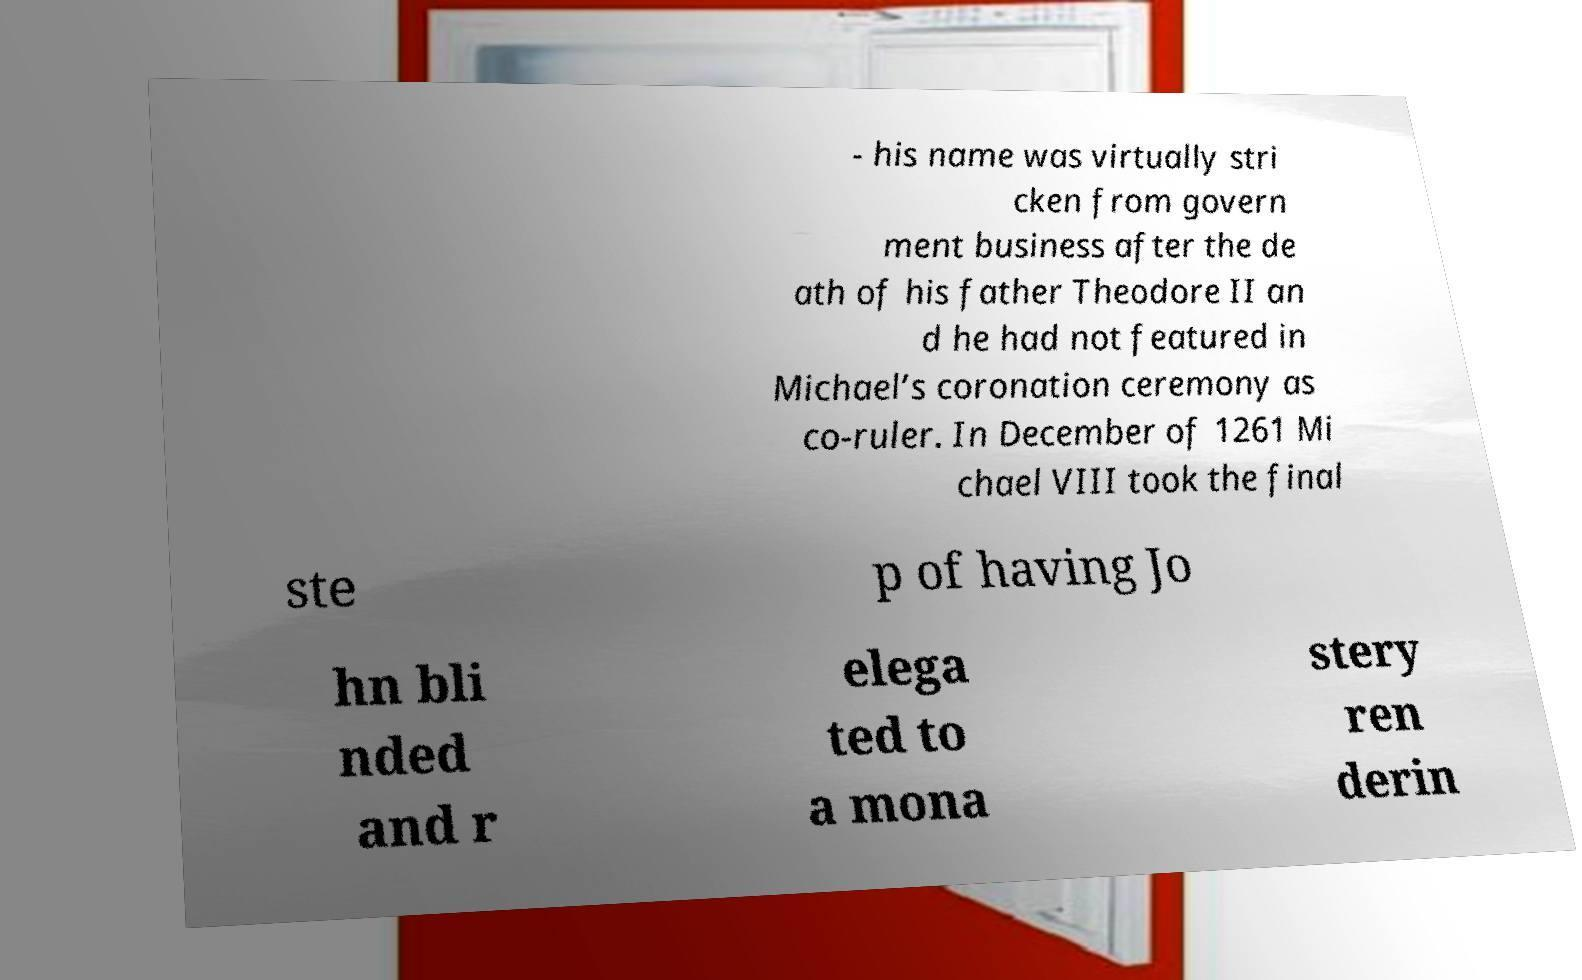What messages or text are displayed in this image? I need them in a readable, typed format. - his name was virtually stri cken from govern ment business after the de ath of his father Theodore II an d he had not featured in Michael’s coronation ceremony as co-ruler. In December of 1261 Mi chael VIII took the final ste p of having Jo hn bli nded and r elega ted to a mona stery ren derin 